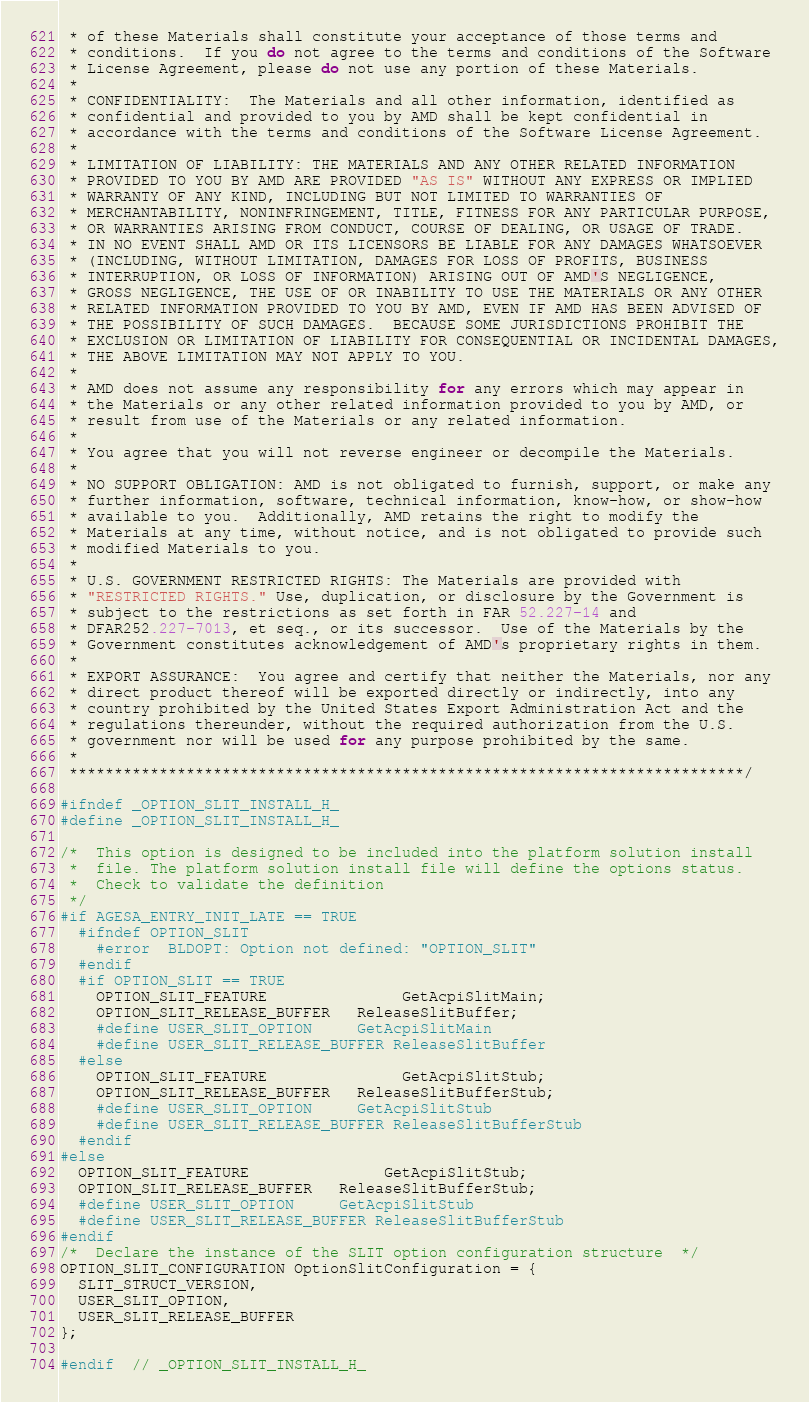<code> <loc_0><loc_0><loc_500><loc_500><_C_> * of these Materials shall constitute your acceptance of those terms and
 * conditions.  If you do not agree to the terms and conditions of the Software
 * License Agreement, please do not use any portion of these Materials.
 *
 * CONFIDENTIALITY:  The Materials and all other information, identified as
 * confidential and provided to you by AMD shall be kept confidential in
 * accordance with the terms and conditions of the Software License Agreement.
 *
 * LIMITATION OF LIABILITY: THE MATERIALS AND ANY OTHER RELATED INFORMATION
 * PROVIDED TO YOU BY AMD ARE PROVIDED "AS IS" WITHOUT ANY EXPRESS OR IMPLIED
 * WARRANTY OF ANY KIND, INCLUDING BUT NOT LIMITED TO WARRANTIES OF
 * MERCHANTABILITY, NONINFRINGEMENT, TITLE, FITNESS FOR ANY PARTICULAR PURPOSE,
 * OR WARRANTIES ARISING FROM CONDUCT, COURSE OF DEALING, OR USAGE OF TRADE.
 * IN NO EVENT SHALL AMD OR ITS LICENSORS BE LIABLE FOR ANY DAMAGES WHATSOEVER
 * (INCLUDING, WITHOUT LIMITATION, DAMAGES FOR LOSS OF PROFITS, BUSINESS
 * INTERRUPTION, OR LOSS OF INFORMATION) ARISING OUT OF AMD'S NEGLIGENCE,
 * GROSS NEGLIGENCE, THE USE OF OR INABILITY TO USE THE MATERIALS OR ANY OTHER
 * RELATED INFORMATION PROVIDED TO YOU BY AMD, EVEN IF AMD HAS BEEN ADVISED OF
 * THE POSSIBILITY OF SUCH DAMAGES.  BECAUSE SOME JURISDICTIONS PROHIBIT THE
 * EXCLUSION OR LIMITATION OF LIABILITY FOR CONSEQUENTIAL OR INCIDENTAL DAMAGES,
 * THE ABOVE LIMITATION MAY NOT APPLY TO YOU.
 *
 * AMD does not assume any responsibility for any errors which may appear in
 * the Materials or any other related information provided to you by AMD, or
 * result from use of the Materials or any related information.
 *
 * You agree that you will not reverse engineer or decompile the Materials.
 *
 * NO SUPPORT OBLIGATION: AMD is not obligated to furnish, support, or make any
 * further information, software, technical information, know-how, or show-how
 * available to you.  Additionally, AMD retains the right to modify the
 * Materials at any time, without notice, and is not obligated to provide such
 * modified Materials to you.
 *
 * U.S. GOVERNMENT RESTRICTED RIGHTS: The Materials are provided with
 * "RESTRICTED RIGHTS." Use, duplication, or disclosure by the Government is
 * subject to the restrictions as set forth in FAR 52.227-14 and
 * DFAR252.227-7013, et seq., or its successor.  Use of the Materials by the
 * Government constitutes acknowledgement of AMD's proprietary rights in them.
 *
 * EXPORT ASSURANCE:  You agree and certify that neither the Materials, nor any
 * direct product thereof will be exported directly or indirectly, into any
 * country prohibited by the United States Export Administration Act and the
 * regulations thereunder, without the required authorization from the U.S.
 * government nor will be used for any purpose prohibited by the same.
 *
 ***************************************************************************/

#ifndef _OPTION_SLIT_INSTALL_H_
#define _OPTION_SLIT_INSTALL_H_

/*  This option is designed to be included into the platform solution install
 *  file. The platform solution install file will define the options status.
 *  Check to validate the definition
 */
#if AGESA_ENTRY_INIT_LATE == TRUE
  #ifndef OPTION_SLIT
    #error  BLDOPT: Option not defined: "OPTION_SLIT"
  #endif
  #if OPTION_SLIT == TRUE
    OPTION_SLIT_FEATURE               GetAcpiSlitMain;
    OPTION_SLIT_RELEASE_BUFFER   ReleaseSlitBuffer;
    #define USER_SLIT_OPTION     GetAcpiSlitMain
    #define USER_SLIT_RELEASE_BUFFER ReleaseSlitBuffer
  #else
    OPTION_SLIT_FEATURE               GetAcpiSlitStub;
    OPTION_SLIT_RELEASE_BUFFER   ReleaseSlitBufferStub;
    #define USER_SLIT_OPTION     GetAcpiSlitStub
    #define USER_SLIT_RELEASE_BUFFER ReleaseSlitBufferStub
  #endif
#else
  OPTION_SLIT_FEATURE               GetAcpiSlitStub;
  OPTION_SLIT_RELEASE_BUFFER   ReleaseSlitBufferStub;
  #define USER_SLIT_OPTION     GetAcpiSlitStub
  #define USER_SLIT_RELEASE_BUFFER ReleaseSlitBufferStub
#endif
/*  Declare the instance of the SLIT option configuration structure  */
OPTION_SLIT_CONFIGURATION OptionSlitConfiguration = {
  SLIT_STRUCT_VERSION,
  USER_SLIT_OPTION,
  USER_SLIT_RELEASE_BUFFER
};

#endif  // _OPTION_SLIT_INSTALL_H_
</code> 